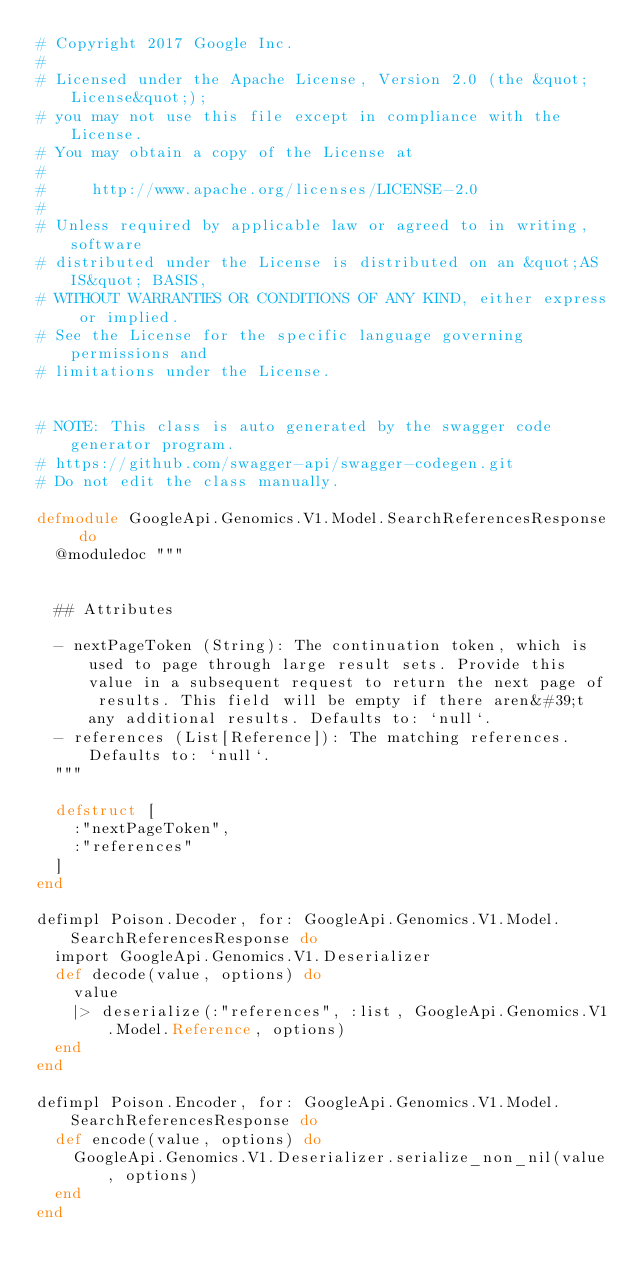Convert code to text. <code><loc_0><loc_0><loc_500><loc_500><_Elixir_># Copyright 2017 Google Inc.
#
# Licensed under the Apache License, Version 2.0 (the &quot;License&quot;);
# you may not use this file except in compliance with the License.
# You may obtain a copy of the License at
#
#     http://www.apache.org/licenses/LICENSE-2.0
#
# Unless required by applicable law or agreed to in writing, software
# distributed under the License is distributed on an &quot;AS IS&quot; BASIS,
# WITHOUT WARRANTIES OR CONDITIONS OF ANY KIND, either express or implied.
# See the License for the specific language governing permissions and
# limitations under the License.


# NOTE: This class is auto generated by the swagger code generator program.
# https://github.com/swagger-api/swagger-codegen.git
# Do not edit the class manually.

defmodule GoogleApi.Genomics.V1.Model.SearchReferencesResponse do
  @moduledoc """
  

  ## Attributes

  - nextPageToken (String): The continuation token, which is used to page through large result sets. Provide this value in a subsequent request to return the next page of results. This field will be empty if there aren&#39;t any additional results. Defaults to: `null`.
  - references (List[Reference]): The matching references. Defaults to: `null`.
  """

  defstruct [
    :"nextPageToken",
    :"references"
  ]
end

defimpl Poison.Decoder, for: GoogleApi.Genomics.V1.Model.SearchReferencesResponse do
  import GoogleApi.Genomics.V1.Deserializer
  def decode(value, options) do
    value
    |> deserialize(:"references", :list, GoogleApi.Genomics.V1.Model.Reference, options)
  end
end

defimpl Poison.Encoder, for: GoogleApi.Genomics.V1.Model.SearchReferencesResponse do
  def encode(value, options) do
    GoogleApi.Genomics.V1.Deserializer.serialize_non_nil(value, options)
  end
end

</code> 